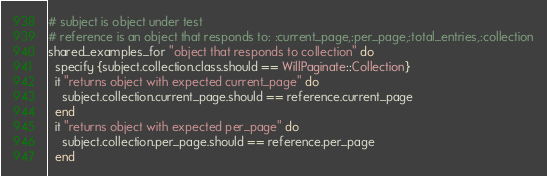Convert code to text. <code><loc_0><loc_0><loc_500><loc_500><_Ruby_># subject is object under test
# reference is an object that responds to: :current_page,:per_page,:total_entries,:collection
shared_examples_for "object that responds to collection" do
  specify {subject.collection.class.should == WillPaginate::Collection}
  it "returns object with expected current_page" do
    subject.collection.current_page.should == reference.current_page
  end
  it "returns object with expected per_page" do
    subject.collection.per_page.should == reference.per_page
  end</code> 